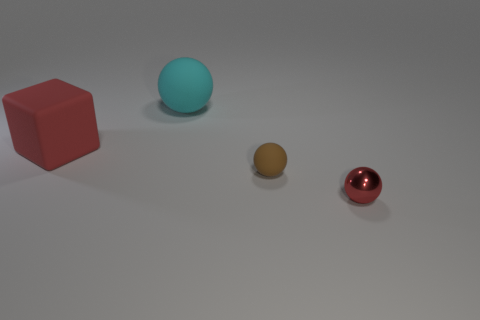There is a small brown thing; what shape is it?
Ensure brevity in your answer.  Sphere. Is the red cube the same size as the brown object?
Ensure brevity in your answer.  No. Are there the same number of small cyan matte blocks and brown objects?
Offer a very short reply. No. What number of other things are there of the same shape as the metallic thing?
Your answer should be compact. 2. What is the shape of the object that is right of the small brown rubber thing?
Your answer should be very brief. Sphere. Do the large rubber object behind the rubber cube and the red object that is to the left of the cyan rubber thing have the same shape?
Ensure brevity in your answer.  No. Are there the same number of big cyan objects that are in front of the tiny brown matte object and cyan objects?
Ensure brevity in your answer.  No. Is there any other thing that is the same size as the brown object?
Your answer should be very brief. Yes. There is a big cyan object that is the same shape as the tiny rubber thing; what material is it?
Offer a terse response. Rubber. There is a large rubber object behind the big cube that is in front of the big sphere; what shape is it?
Your answer should be very brief. Sphere. 